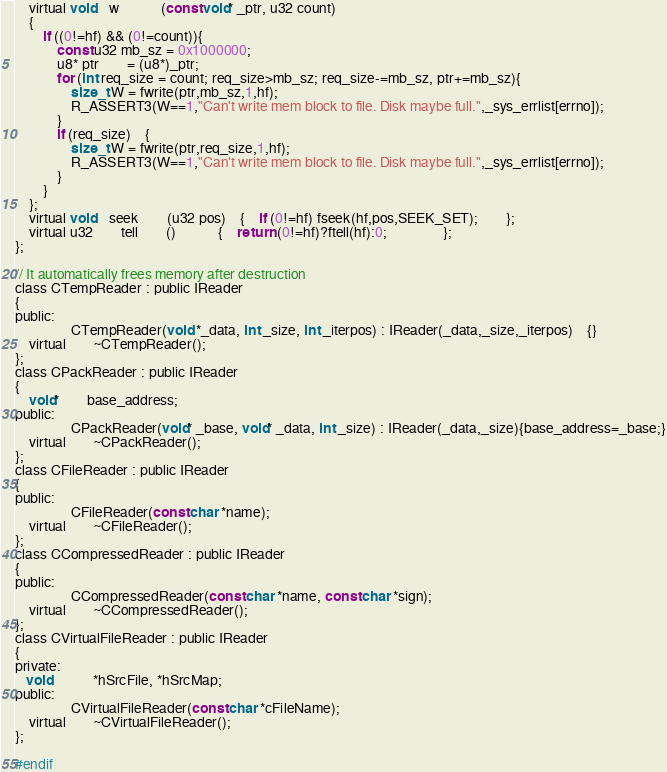Convert code to text. <code><loc_0><loc_0><loc_500><loc_500><_C_>	virtual void	w			(const void* _ptr, u32 count) 
    { 
		if ((0!=hf) && (0!=count)){
			const u32 mb_sz = 0x1000000;
			u8* ptr 		= (u8*)_ptr;
			for (int req_size = count; req_size>mb_sz; req_size-=mb_sz, ptr+=mb_sz){
				size_t W = fwrite(ptr,mb_sz,1,hf);
				R_ASSERT3(W==1,"Can't write mem block to file. Disk maybe full.",_sys_errlist[errno]);
			}
			if (req_size)	{
				size_t W = fwrite(ptr,req_size,1,hf); 
				R_ASSERT3(W==1,"Can't write mem block to file. Disk maybe full.",_sys_errlist[errno]);
			}
		}
    };
	virtual void	seek		(u32 pos)	{	if (0!=hf) fseek(hf,pos,SEEK_SET);		};
	virtual u32		tell		()			{	return (0!=hf)?ftell(hf):0;				};
};

// It automatically frees memory after destruction
class CTempReader : public IReader
{
public:
				CTempReader(void *_data, int _size, int _iterpos) : IReader(_data,_size,_iterpos)	{}
	virtual		~CTempReader();
};
class CPackReader : public IReader
{
	void*		base_address;
public:
				CPackReader(void* _base, void* _data, int _size) : IReader(_data,_size){base_address=_base;}
	virtual		~CPackReader();
};
class CFileReader : public IReader
{
public:
				CFileReader(const char *name);
	virtual		~CFileReader();
};
class CCompressedReader : public IReader
{
public:
				CCompressedReader(const char *name, const char *sign);
	virtual		~CCompressedReader();
};
class CVirtualFileReader : public IReader
{
private:
   void			*hSrcFile, *hSrcMap;
public:
				CVirtualFileReader(const char *cFileName);
	virtual		~CVirtualFileReader();
};

#endif</code> 